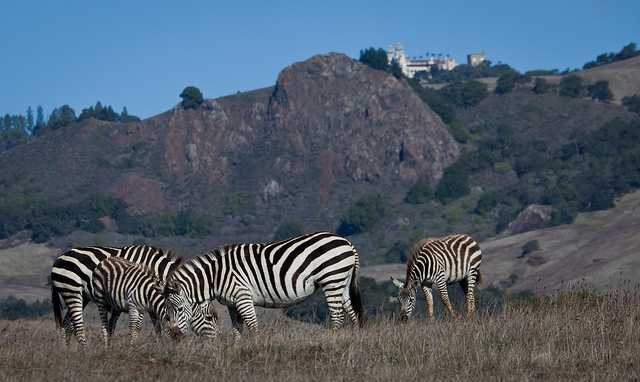Describe the objects in this image and their specific colors. I can see zebra in gray, black, lightgray, and darkgray tones, zebra in gray, black, darkgray, and lightgray tones, zebra in gray, black, and darkgray tones, and zebra in gray, black, and darkgray tones in this image. 